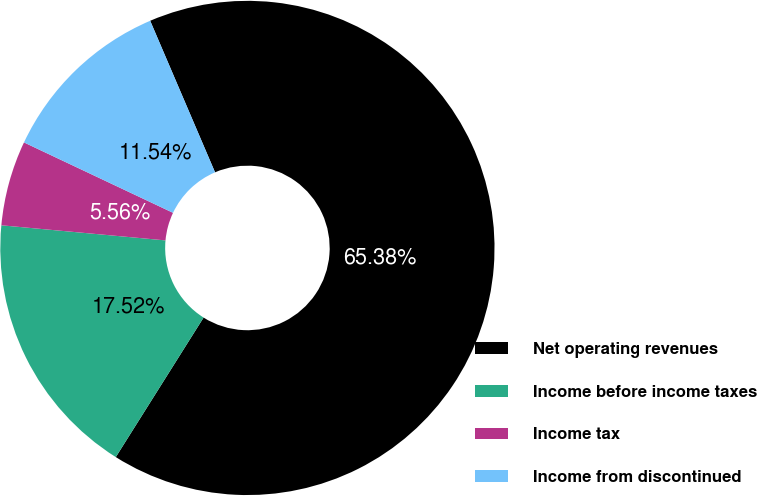<chart> <loc_0><loc_0><loc_500><loc_500><pie_chart><fcel>Net operating revenues<fcel>Income before income taxes<fcel>Income tax<fcel>Income from discontinued<nl><fcel>65.37%<fcel>17.52%<fcel>5.56%<fcel>11.54%<nl></chart> 